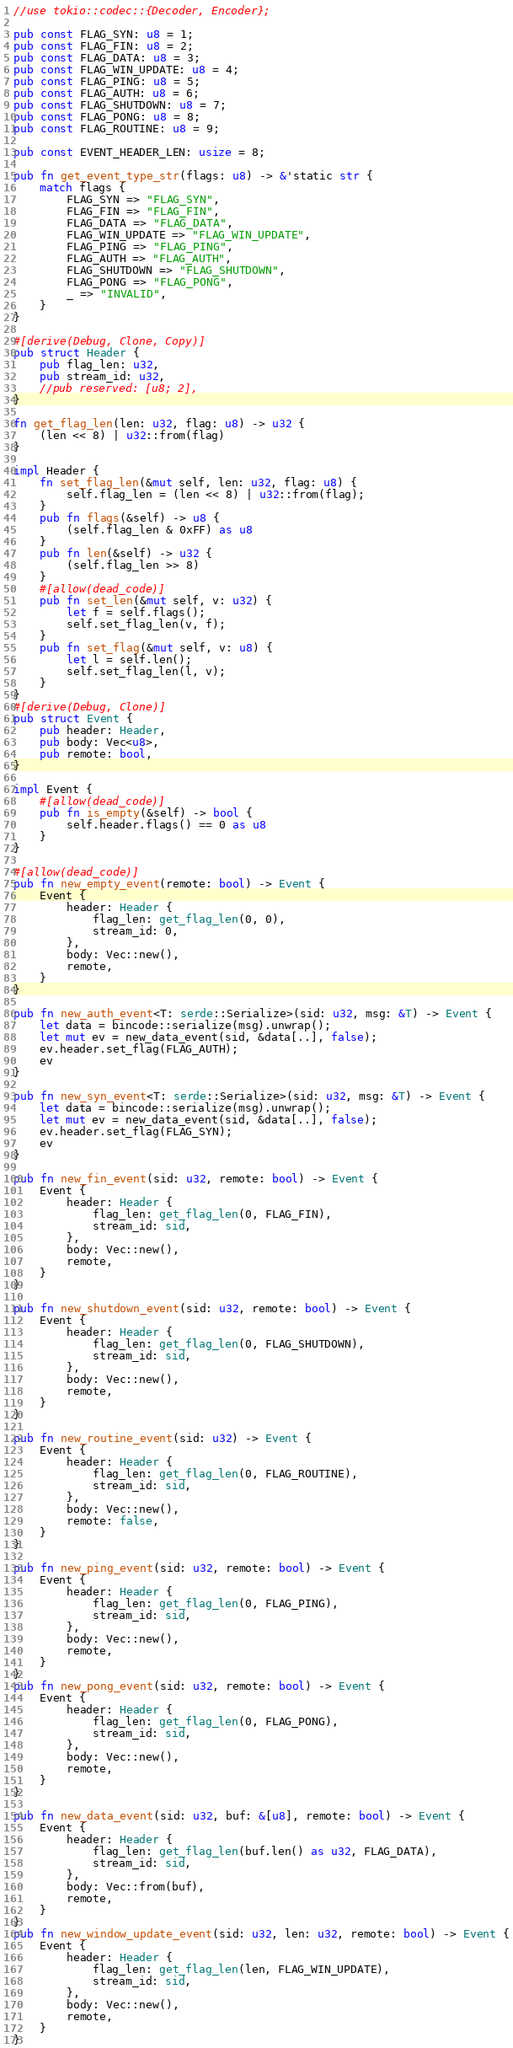Convert code to text. <code><loc_0><loc_0><loc_500><loc_500><_Rust_>//use tokio::codec::{Decoder, Encoder};

pub const FLAG_SYN: u8 = 1;
pub const FLAG_FIN: u8 = 2;
pub const FLAG_DATA: u8 = 3;
pub const FLAG_WIN_UPDATE: u8 = 4;
pub const FLAG_PING: u8 = 5;
pub const FLAG_AUTH: u8 = 6;
pub const FLAG_SHUTDOWN: u8 = 7;
pub const FLAG_PONG: u8 = 8;
pub const FLAG_ROUTINE: u8 = 9;

pub const EVENT_HEADER_LEN: usize = 8;

pub fn get_event_type_str(flags: u8) -> &'static str {
    match flags {
        FLAG_SYN => "FLAG_SYN",
        FLAG_FIN => "FLAG_FIN",
        FLAG_DATA => "FLAG_DATA",
        FLAG_WIN_UPDATE => "FLAG_WIN_UPDATE",
        FLAG_PING => "FLAG_PING",
        FLAG_AUTH => "FLAG_AUTH",
        FLAG_SHUTDOWN => "FLAG_SHUTDOWN",
        FLAG_PONG => "FLAG_PONG",
        _ => "INVALID",
    }
}

#[derive(Debug, Clone, Copy)]
pub struct Header {
    pub flag_len: u32,
    pub stream_id: u32,
    //pub reserved: [u8; 2],
}

fn get_flag_len(len: u32, flag: u8) -> u32 {
    (len << 8) | u32::from(flag)
}

impl Header {
    fn set_flag_len(&mut self, len: u32, flag: u8) {
        self.flag_len = (len << 8) | u32::from(flag);
    }
    pub fn flags(&self) -> u8 {
        (self.flag_len & 0xFF) as u8
    }
    pub fn len(&self) -> u32 {
        (self.flag_len >> 8)
    }
    #[allow(dead_code)]
    pub fn set_len(&mut self, v: u32) {
        let f = self.flags();
        self.set_flag_len(v, f);
    }
    pub fn set_flag(&mut self, v: u8) {
        let l = self.len();
        self.set_flag_len(l, v);
    }
}
#[derive(Debug, Clone)]
pub struct Event {
    pub header: Header,
    pub body: Vec<u8>,
    pub remote: bool,
}

impl Event {
    #[allow(dead_code)]
    pub fn is_empty(&self) -> bool {
        self.header.flags() == 0 as u8
    }
}

#[allow(dead_code)]
pub fn new_empty_event(remote: bool) -> Event {
    Event {
        header: Header {
            flag_len: get_flag_len(0, 0),
            stream_id: 0,
        },
        body: Vec::new(),
        remote,
    }
}

pub fn new_auth_event<T: serde::Serialize>(sid: u32, msg: &T) -> Event {
    let data = bincode::serialize(msg).unwrap();
    let mut ev = new_data_event(sid, &data[..], false);
    ev.header.set_flag(FLAG_AUTH);
    ev
}

pub fn new_syn_event<T: serde::Serialize>(sid: u32, msg: &T) -> Event {
    let data = bincode::serialize(msg).unwrap();
    let mut ev = new_data_event(sid, &data[..], false);
    ev.header.set_flag(FLAG_SYN);
    ev
}

pub fn new_fin_event(sid: u32, remote: bool) -> Event {
    Event {
        header: Header {
            flag_len: get_flag_len(0, FLAG_FIN),
            stream_id: sid,
        },
        body: Vec::new(),
        remote,
    }
}

pub fn new_shutdown_event(sid: u32, remote: bool) -> Event {
    Event {
        header: Header {
            flag_len: get_flag_len(0, FLAG_SHUTDOWN),
            stream_id: sid,
        },
        body: Vec::new(),
        remote,
    }
}

pub fn new_routine_event(sid: u32) -> Event {
    Event {
        header: Header {
            flag_len: get_flag_len(0, FLAG_ROUTINE),
            stream_id: sid,
        },
        body: Vec::new(),
        remote: false,
    }
}

pub fn new_ping_event(sid: u32, remote: bool) -> Event {
    Event {
        header: Header {
            flag_len: get_flag_len(0, FLAG_PING),
            stream_id: sid,
        },
        body: Vec::new(),
        remote,
    }
}
pub fn new_pong_event(sid: u32, remote: bool) -> Event {
    Event {
        header: Header {
            flag_len: get_flag_len(0, FLAG_PONG),
            stream_id: sid,
        },
        body: Vec::new(),
        remote,
    }
}

pub fn new_data_event(sid: u32, buf: &[u8], remote: bool) -> Event {
    Event {
        header: Header {
            flag_len: get_flag_len(buf.len() as u32, FLAG_DATA),
            stream_id: sid,
        },
        body: Vec::from(buf),
        remote,
    }
}
pub fn new_window_update_event(sid: u32, len: u32, remote: bool) -> Event {
    Event {
        header: Header {
            flag_len: get_flag_len(len, FLAG_WIN_UPDATE),
            stream_id: sid,
        },
        body: Vec::new(),
        remote,
    }
}
</code> 